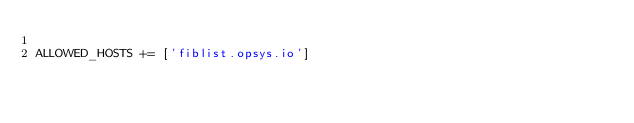<code> <loc_0><loc_0><loc_500><loc_500><_Python_>
ALLOWED_HOSTS += ['fiblist.opsys.io']</code> 